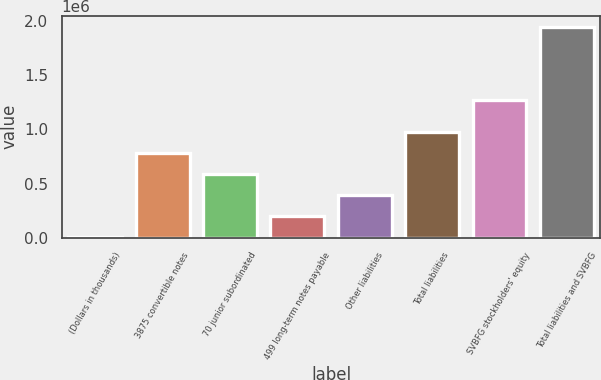Convert chart. <chart><loc_0><loc_0><loc_500><loc_500><bar_chart><fcel>(Dollars in thousands)<fcel>3875 convertible notes<fcel>70 junior subordinated<fcel>499 long-term notes payable<fcel>Other liabilities<fcel>Total liabilities<fcel>SVBFG stockholders' equity<fcel>Total liabilities and SVBFG<nl><fcel>2010<fcel>781538<fcel>586656<fcel>196892<fcel>391774<fcel>976420<fcel>1.27435e+06<fcel>1.95083e+06<nl></chart> 